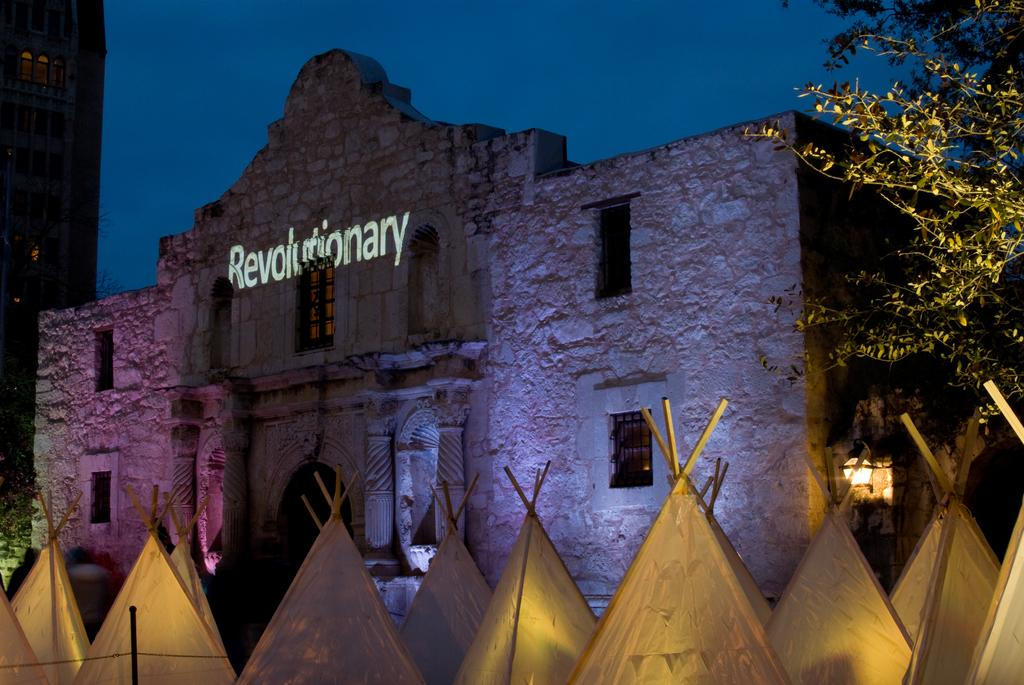<image>
Provide a brief description of the given image. A building with several tee-pees outside is labelled Revolutionary. 